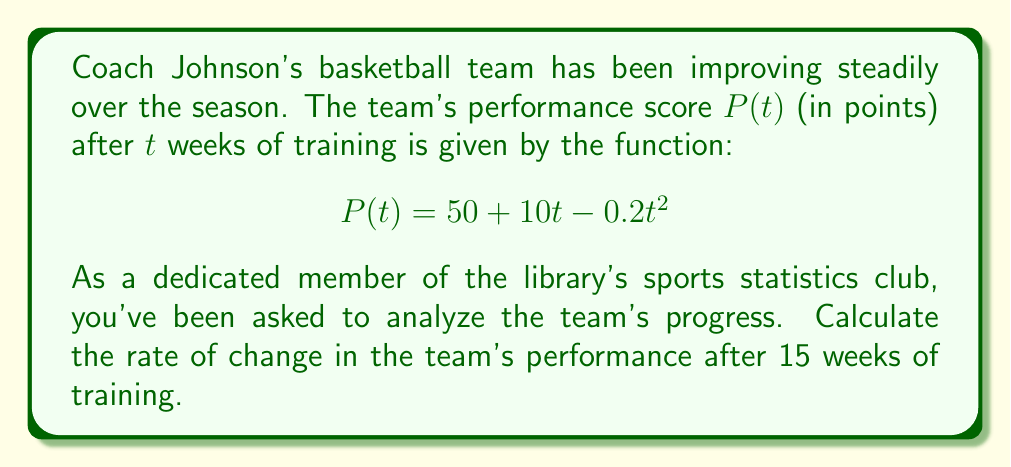Give your solution to this math problem. To solve this problem, we need to follow these steps:

1) The rate of change in the team's performance is given by the derivative of the performance function $P(t)$.

2) Let's find the derivative of $P(t)$:
   
   $$P(t) = 50 + 10t - 0.2t^2$$
   
   $$\frac{d}{dt}P(t) = \frac{d}{dt}(50) + \frac{d}{dt}(10t) - \frac{d}{dt}(0.2t^2)$$
   
   $$P'(t) = 0 + 10 - 0.4t$$
   
   $$P'(t) = 10 - 0.4t$$

3) Now that we have the derivative, we can find the rate of change at 15 weeks by substituting $t=15$ into $P'(t)$:

   $$P'(15) = 10 - 0.4(15)$$
   
   $$P'(15) = 10 - 6$$
   
   $$P'(15) = 4$$

4) The rate of change is positive, indicating that the team's performance is still improving after 15 weeks, but at a slower rate than initially.
Answer: The rate of change in the team's performance after 15 weeks of training is 4 points per week. 